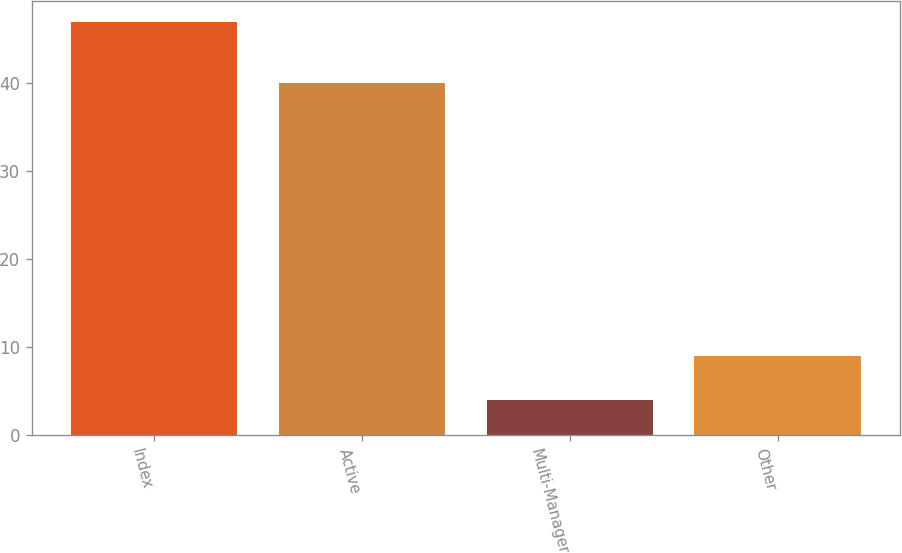Convert chart. <chart><loc_0><loc_0><loc_500><loc_500><bar_chart><fcel>Index<fcel>Active<fcel>Multi-Manager<fcel>Other<nl><fcel>47<fcel>40<fcel>4<fcel>9<nl></chart> 